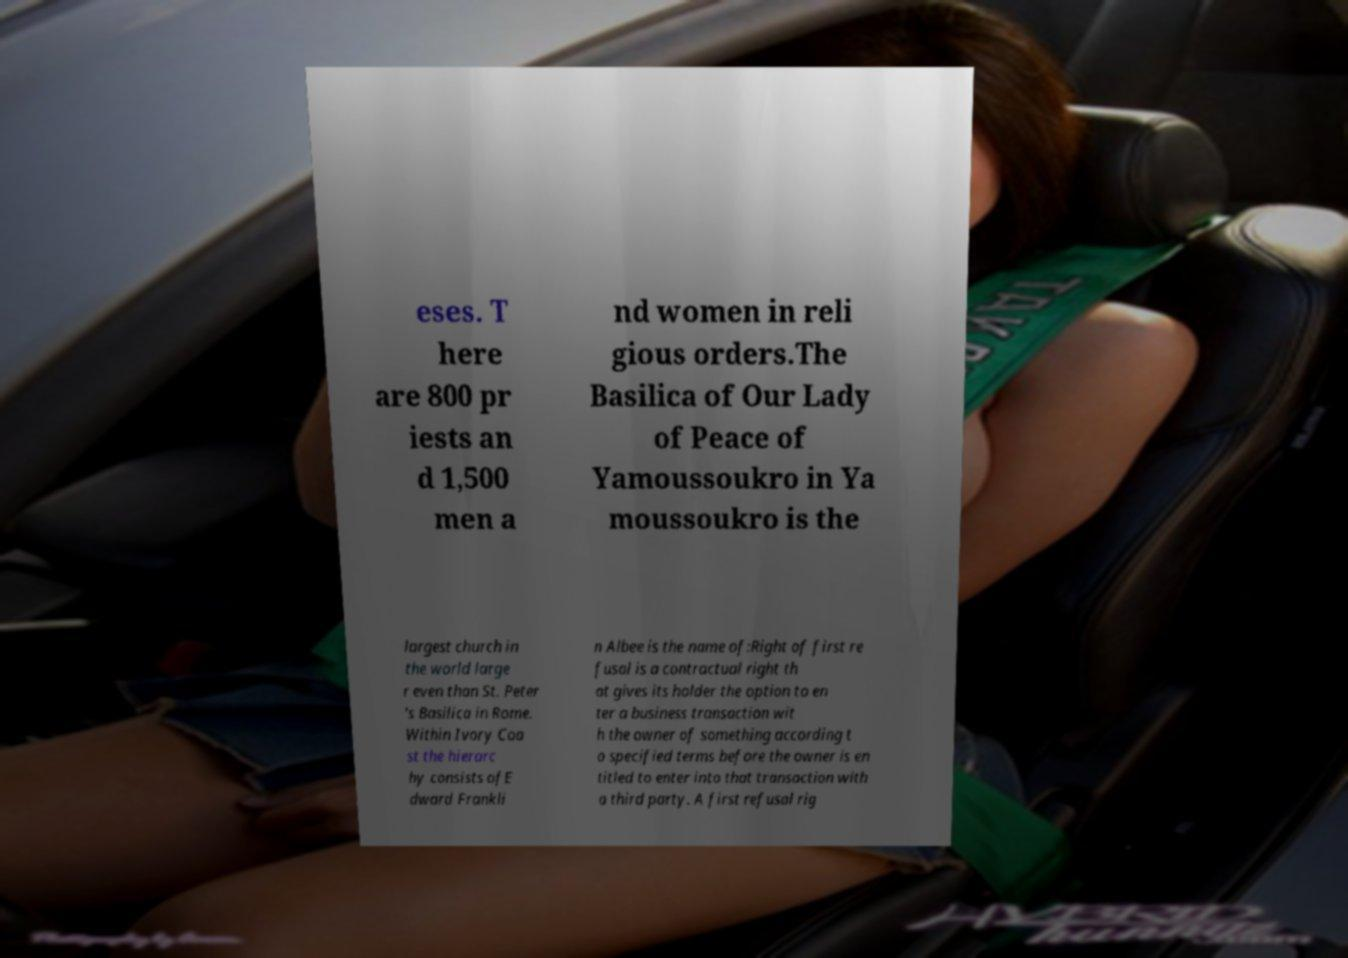Could you assist in decoding the text presented in this image and type it out clearly? eses. T here are 800 pr iests an d 1,500 men a nd women in reli gious orders.The Basilica of Our Lady of Peace of Yamoussoukro in Ya moussoukro is the largest church in the world large r even than St. Peter 's Basilica in Rome. Within Ivory Coa st the hierarc hy consists ofE dward Frankli n Albee is the name of:Right of first re fusal is a contractual right th at gives its holder the option to en ter a business transaction wit h the owner of something according t o specified terms before the owner is en titled to enter into that transaction with a third party. A first refusal rig 